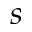Convert formula to latex. <formula><loc_0><loc_0><loc_500><loc_500>s</formula> 